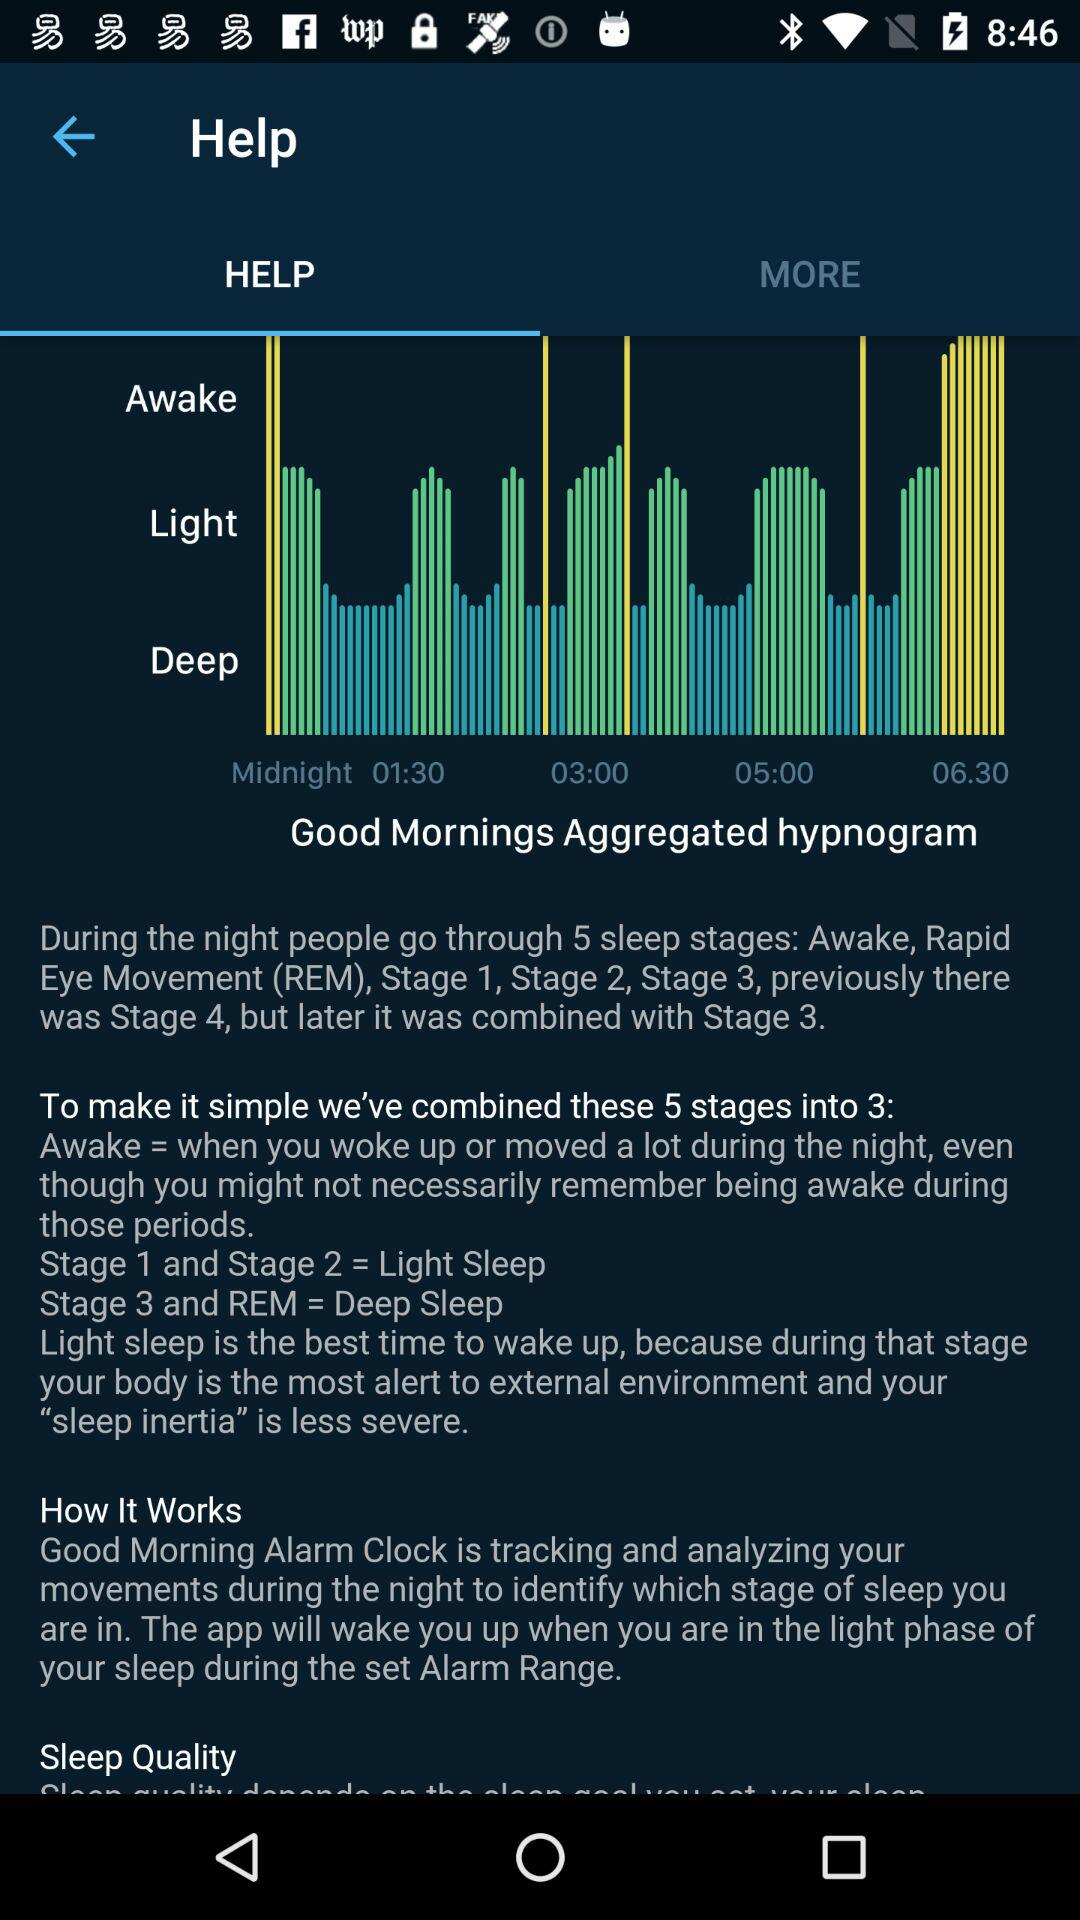How many stages of sleep are displayed on the graph?
Answer the question using a single word or phrase. 3 